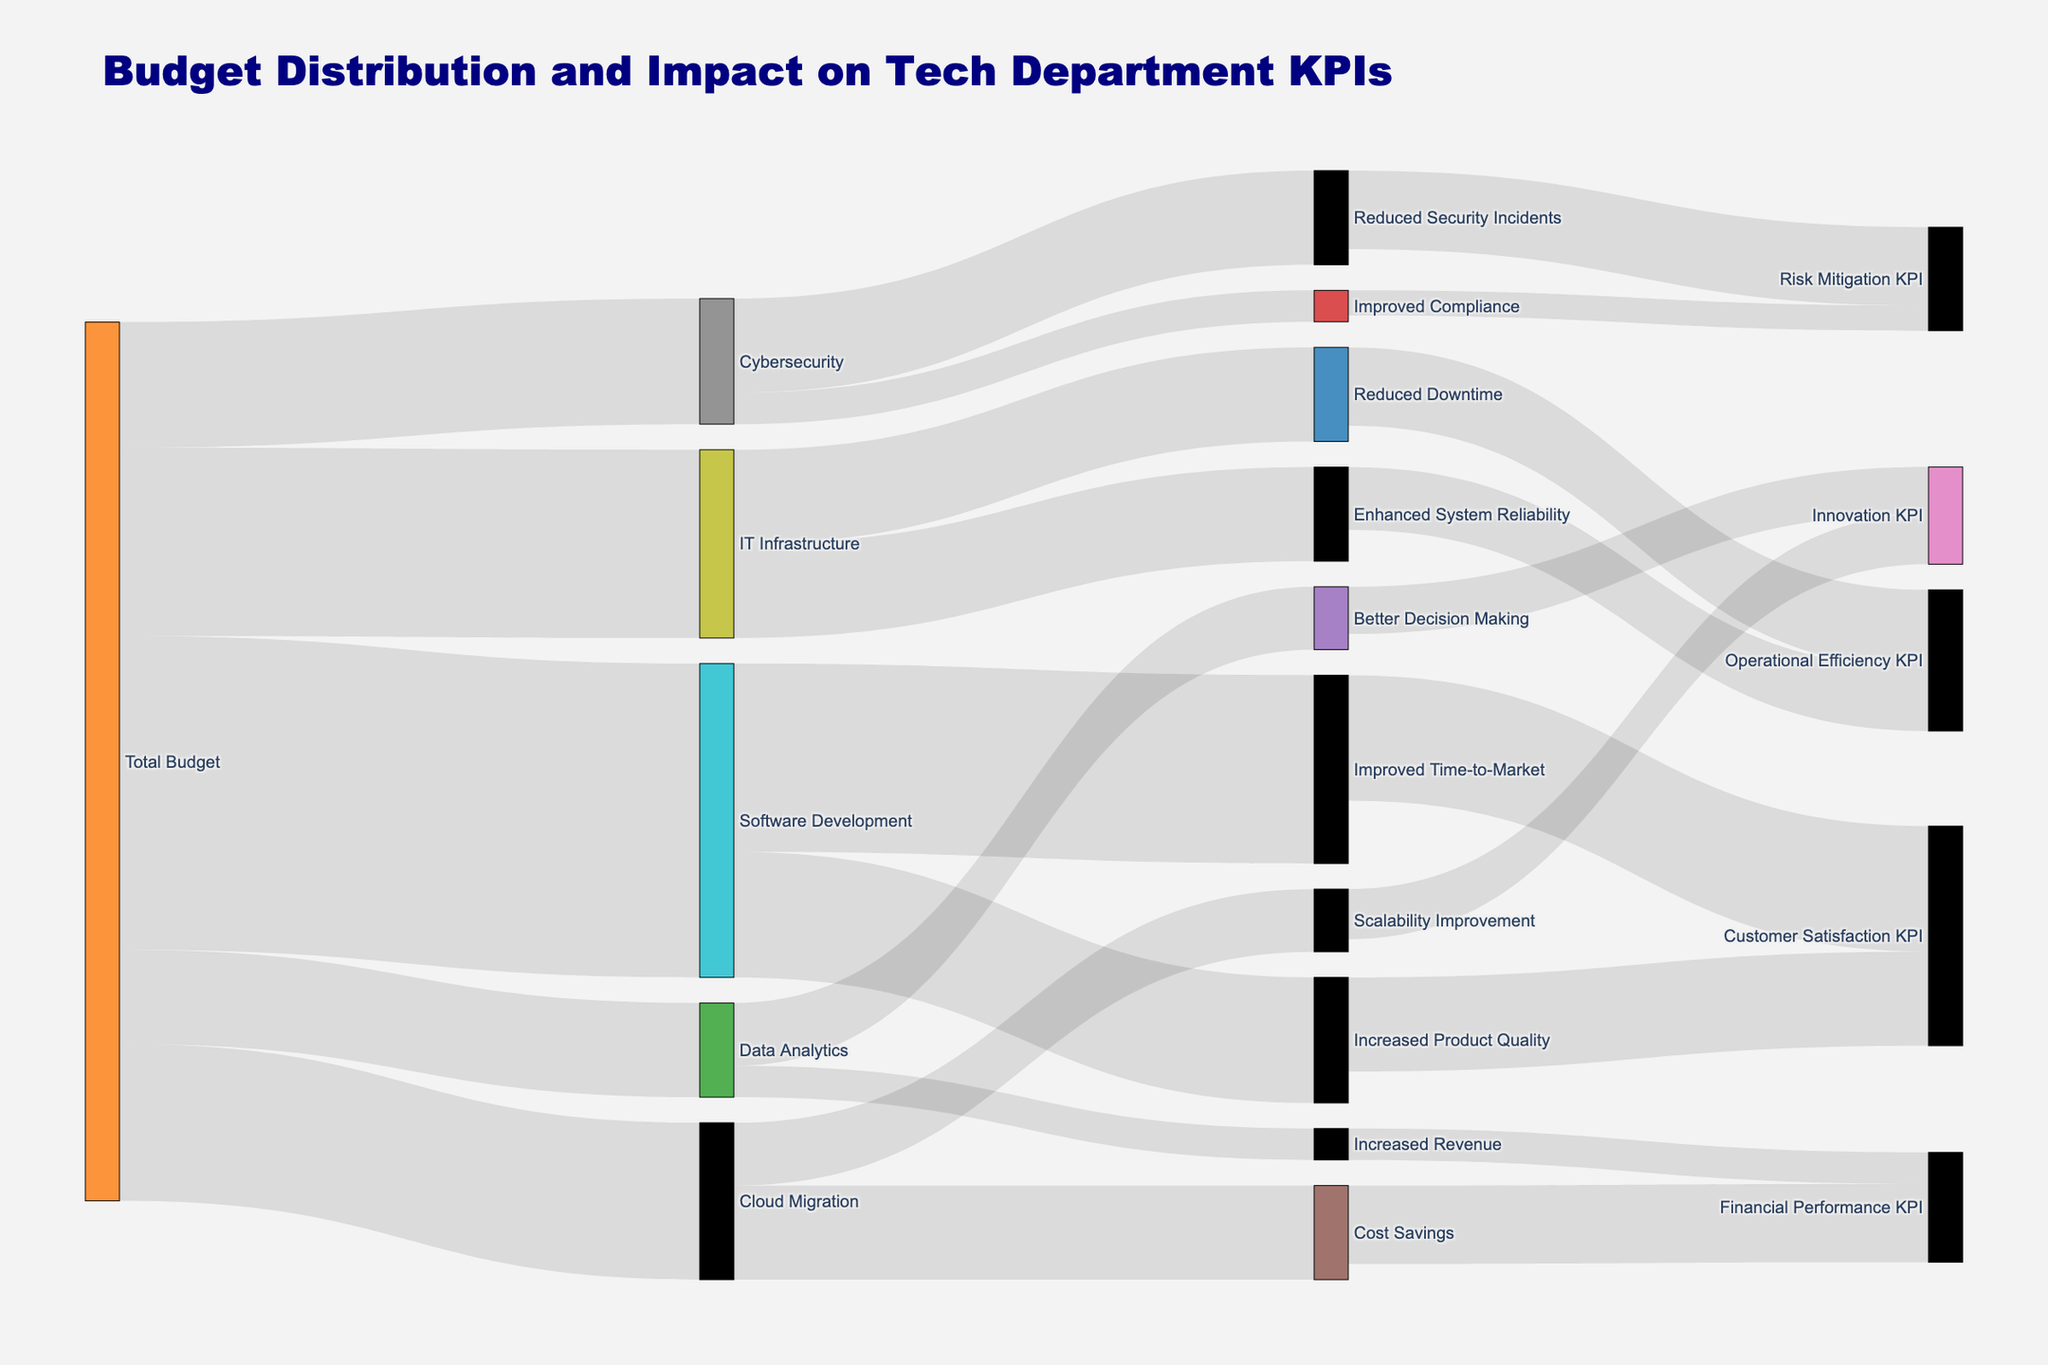What is the total budget allocated to Data Analytics? The figure shows a branch from 'Total Budget' to 'Data Analytics' with the value labeled as 150,000.
Answer: 150,000 Which KPI is most impacted by Software Development? From 'Software Development', the largest flow goes to 'Improved Time-to-Market' with a value of 300,000, which then significantly impacts 'Customer Satisfaction KPI' by 200,000.
Answer: Customer Satisfaction KPI How does the 'Cloud Migration' initiative primarily impact the departmental KPIs? The figure shows that 'Cloud Migration' branches to 'Cost Savings' and 'Scalability Improvement'. 'Cost Savings' has a higher impact, contributing 125,000 to 'Financial Performance KPI'.
Answer: Financial Performance KPI Which initiative received the lowest amount of budget from the total budget? From the 'Total Budget' node, 'Data Analytics' has the smallest value of 150,000 allocated.
Answer: Data Analytics Compare the budget allocation between 'IT Infrastructure' and 'Software Development'. The 'Total Budget' allocates 300,000 to 'IT Infrastructure' and 500,000 to 'Software Development'. Comparing these values, 'Software Development' has a higher allocation.
Answer: Software Development Calculate the total budget impacting 'Operational Efficiency KPI'. The 'Operational Efficiency KPI' is influenced by 'Enhanced System Reliability' (100,000) and 'Reduced Downtime' (125,000). Summing these values: 100,000 + 125,000 = 225,000.
Answer: 225,000 What are the two main impacts of 'Cybersecurity' on the departmental KPIs? 'Cybersecurity' impacts 'Reduced Security Incidents' and 'Improved Compliance'. They, in turn, impact 'Risk Mitigation KPI' with values of 125,000 and 40,000 respectively.
Answer: Risk Mitigation KPI Identify which initiative directly contributes to the 'Financial Performance KPI' and by how much. Both 'Increased Revenue' from 'Data Analytics' and 'Cost Savings' from 'Cloud Migration' contribute directly to 'Financial Performance KPI' with values of 50,000 and 125,000, respectively.
Answer: Increased Revenue (50,000) and Cost Savings (125,000) Which initiative contributes equally to multiple impacts? The 'IT Infrastructure' initiative contributes equally to 'Enhanced System Reliability' and 'Reduced Downtime', both with values of 150,000.
Answer: IT Infrastructure Compare the impact of 'Improved Time-to-Market' and 'Increased Product Quality' on 'Customer Satisfaction KPI'. 'Improved Time-to-Market' impacts 'Customer Satisfaction KPI' by 200,000, while 'Increased Product Quality' impacts it by 150,000. Therefore, 'Improved Time-to-Market' has a larger impact.
Answer: Improved Time-to-Market 